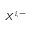<formula> <loc_0><loc_0><loc_500><loc_500>X ^ { i , - }</formula> 